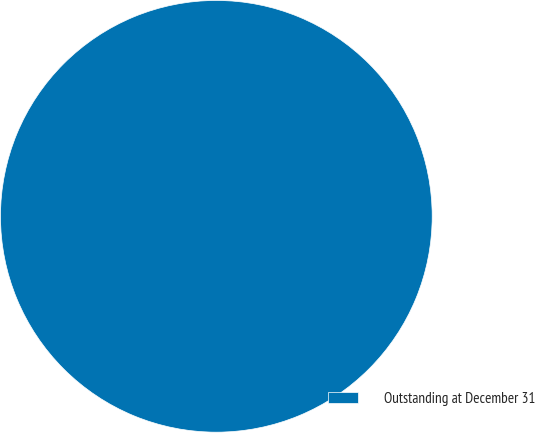Convert chart. <chart><loc_0><loc_0><loc_500><loc_500><pie_chart><fcel>Outstanding at December 31<nl><fcel>100.0%<nl></chart> 